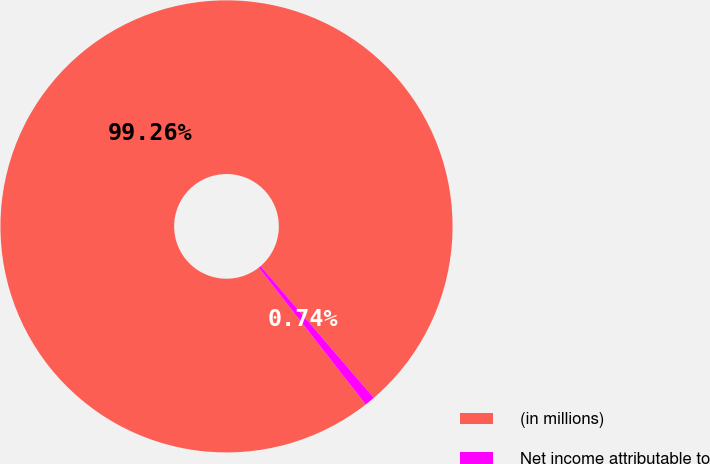Convert chart to OTSL. <chart><loc_0><loc_0><loc_500><loc_500><pie_chart><fcel>(in millions)<fcel>Net income attributable to<nl><fcel>99.26%<fcel>0.74%<nl></chart> 